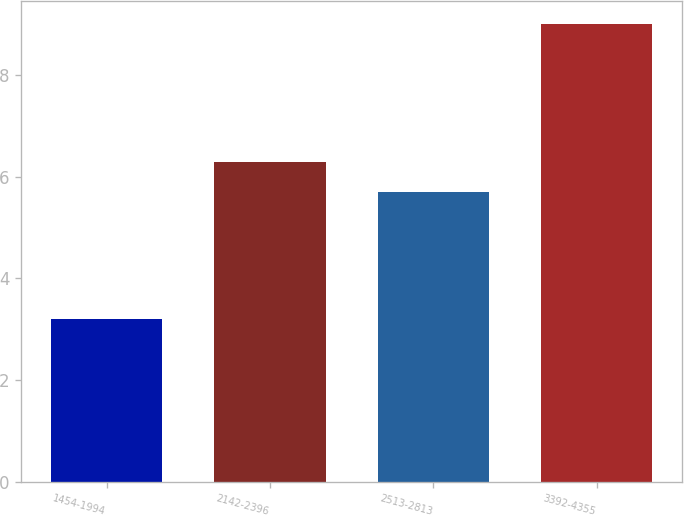Convert chart. <chart><loc_0><loc_0><loc_500><loc_500><bar_chart><fcel>1454-1994<fcel>2142-2396<fcel>2513-2813<fcel>3392-4355<nl><fcel>3.2<fcel>6.3<fcel>5.7<fcel>9<nl></chart> 